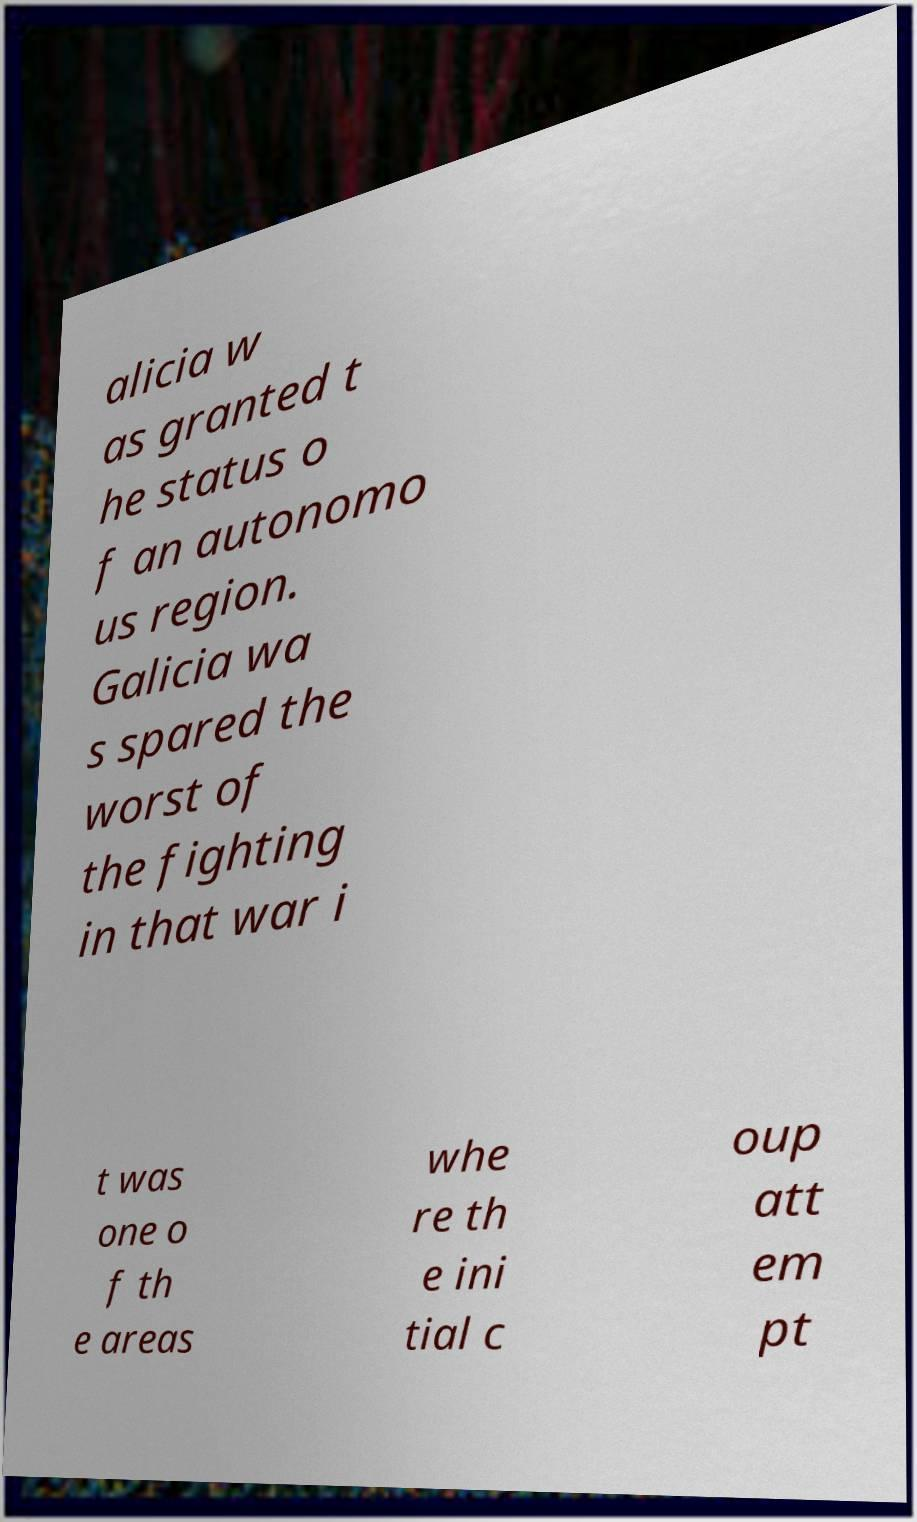What messages or text are displayed in this image? I need them in a readable, typed format. alicia w as granted t he status o f an autonomo us region. Galicia wa s spared the worst of the fighting in that war i t was one o f th e areas whe re th e ini tial c oup att em pt 